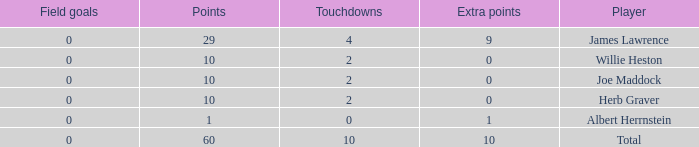What is the average number of field goals for players with more than 60 points? None. 